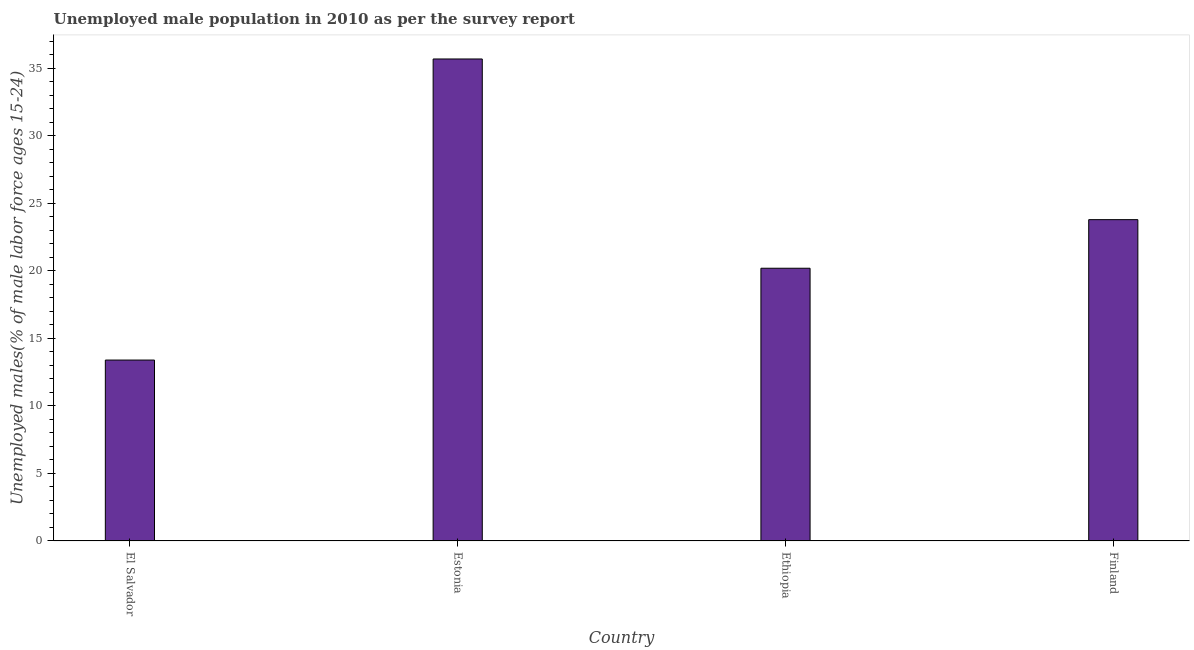Does the graph contain any zero values?
Give a very brief answer. No. What is the title of the graph?
Provide a short and direct response. Unemployed male population in 2010 as per the survey report. What is the label or title of the X-axis?
Your answer should be very brief. Country. What is the label or title of the Y-axis?
Keep it short and to the point. Unemployed males(% of male labor force ages 15-24). What is the unemployed male youth in Estonia?
Keep it short and to the point. 35.7. Across all countries, what is the maximum unemployed male youth?
Your answer should be compact. 35.7. Across all countries, what is the minimum unemployed male youth?
Offer a very short reply. 13.4. In which country was the unemployed male youth maximum?
Make the answer very short. Estonia. In which country was the unemployed male youth minimum?
Provide a succinct answer. El Salvador. What is the sum of the unemployed male youth?
Make the answer very short. 93.1. What is the difference between the unemployed male youth in El Salvador and Estonia?
Keep it short and to the point. -22.3. What is the average unemployed male youth per country?
Your answer should be compact. 23.27. In how many countries, is the unemployed male youth greater than 10 %?
Offer a terse response. 4. What is the ratio of the unemployed male youth in Ethiopia to that in Finland?
Provide a succinct answer. 0.85. Is the sum of the unemployed male youth in Estonia and Finland greater than the maximum unemployed male youth across all countries?
Keep it short and to the point. Yes. What is the difference between the highest and the lowest unemployed male youth?
Provide a short and direct response. 22.3. In how many countries, is the unemployed male youth greater than the average unemployed male youth taken over all countries?
Your response must be concise. 2. How many bars are there?
Your response must be concise. 4. What is the difference between two consecutive major ticks on the Y-axis?
Your response must be concise. 5. What is the Unemployed males(% of male labor force ages 15-24) in El Salvador?
Offer a terse response. 13.4. What is the Unemployed males(% of male labor force ages 15-24) in Estonia?
Your answer should be compact. 35.7. What is the Unemployed males(% of male labor force ages 15-24) of Ethiopia?
Your answer should be compact. 20.2. What is the Unemployed males(% of male labor force ages 15-24) in Finland?
Offer a terse response. 23.8. What is the difference between the Unemployed males(% of male labor force ages 15-24) in El Salvador and Estonia?
Offer a very short reply. -22.3. What is the difference between the Unemployed males(% of male labor force ages 15-24) in El Salvador and Finland?
Keep it short and to the point. -10.4. What is the difference between the Unemployed males(% of male labor force ages 15-24) in Estonia and Finland?
Ensure brevity in your answer.  11.9. What is the ratio of the Unemployed males(% of male labor force ages 15-24) in El Salvador to that in Estonia?
Provide a short and direct response. 0.38. What is the ratio of the Unemployed males(% of male labor force ages 15-24) in El Salvador to that in Ethiopia?
Provide a short and direct response. 0.66. What is the ratio of the Unemployed males(% of male labor force ages 15-24) in El Salvador to that in Finland?
Keep it short and to the point. 0.56. What is the ratio of the Unemployed males(% of male labor force ages 15-24) in Estonia to that in Ethiopia?
Offer a very short reply. 1.77. What is the ratio of the Unemployed males(% of male labor force ages 15-24) in Ethiopia to that in Finland?
Offer a terse response. 0.85. 